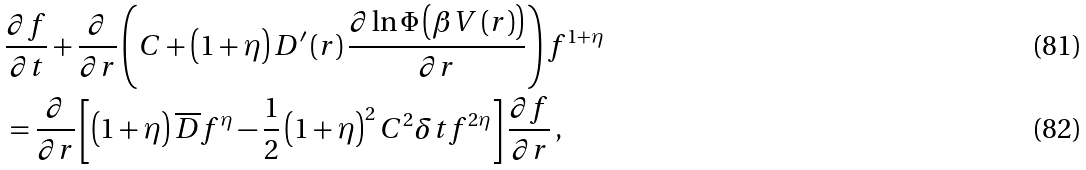<formula> <loc_0><loc_0><loc_500><loc_500>& \frac { \partial f } { \partial t } + \frac { \partial } { \partial r } \left ( C + \left ( 1 + \eta \right ) D ^ { \prime } \left ( r \right ) \frac { \partial \ln \Phi \left ( \beta V \left ( r \right ) \right ) } { \partial r } \right ) f ^ { 1 + \eta } \\ & = \frac { \partial } { \partial r } \left [ \left ( 1 + \eta \right ) \overline { D } f ^ { \eta } - \frac { 1 } { 2 } \left ( 1 + \eta \right ) ^ { 2 } C ^ { 2 } \delta t f ^ { 2 \eta } \right ] \frac { \partial f } { \partial r } \, ,</formula> 